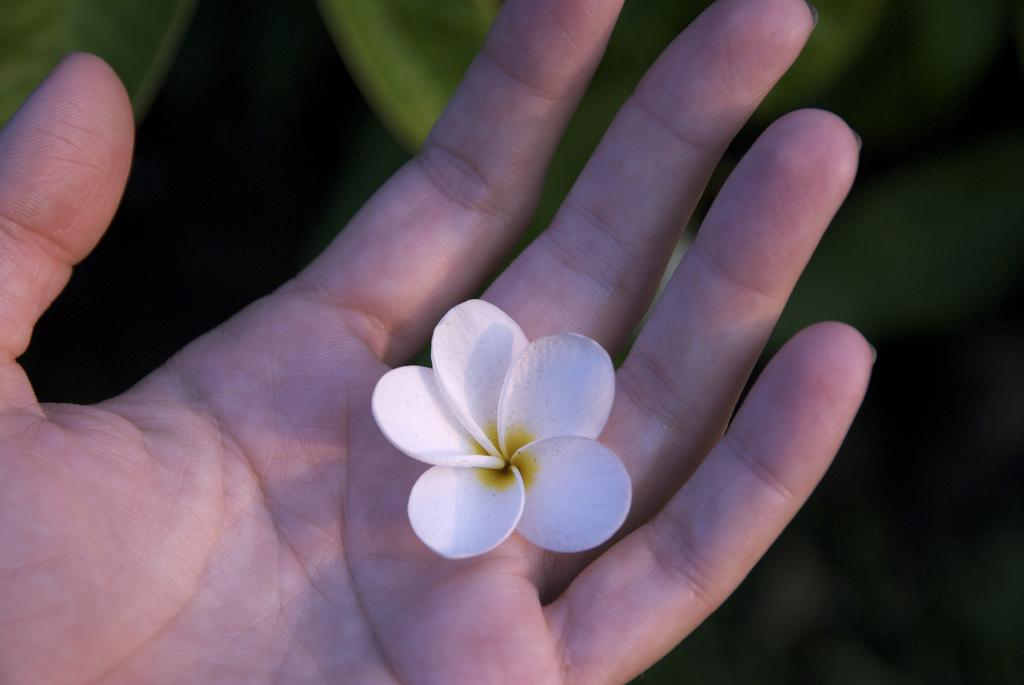What is the visual effect on the background of the image? The background portion of the picture is blurred. What type of vegetation can be seen in the image? Green leaves are visible in the image. Whose hand is present in the image? There is a person's hand in the image. What is the main object of focus in the image? A flower is present in the image. How many dimes are scattered among the leaves in the image? There are no dimes present in the image; only green leaves, a person's hand, and a flower can be seen. 